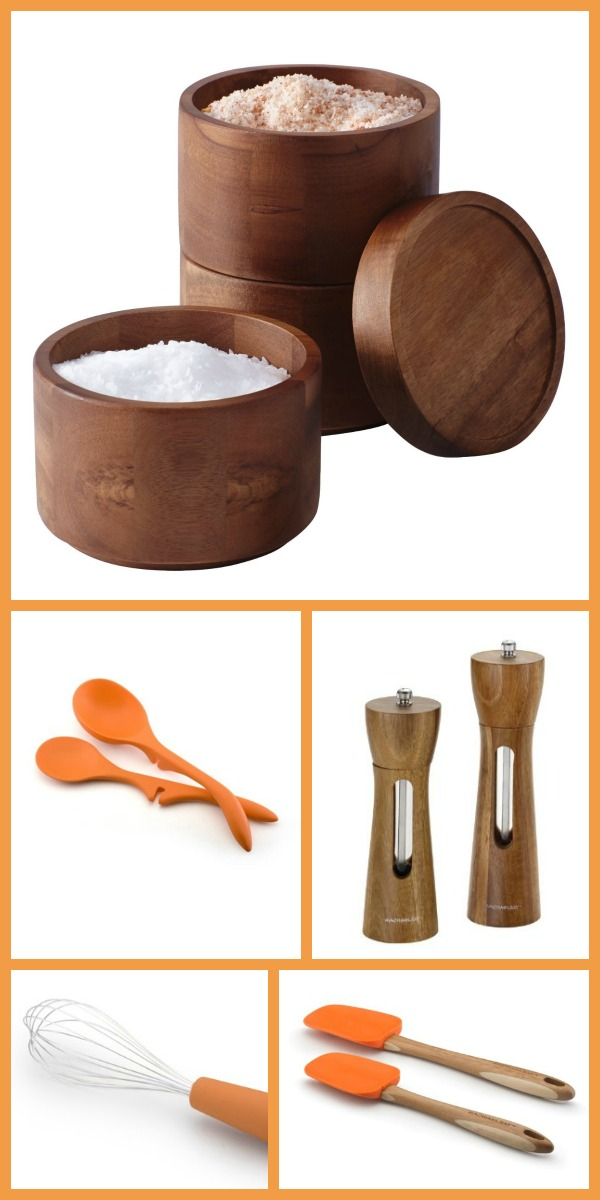Imagine that each item in the image had a personality. Describe the interactions they might have in a kitchen setting. In a magical kitchen, the wooden containers would be the wise and sturdy elders, offering seasoned advice and keeping the spices in order. The silicone utensils, with their bright orange color, would be the energetic and playful youngsters, always ready to help with cooking adventures. The pepper and salt grinders would take on the role of sophisticated food critics, dispensing seasonings with a touch of class. Meanwhile, the whisk, with its dynamic shape, would act as the master organizer, ensuring everything is well-mixed and harmonious in the culinary world. 